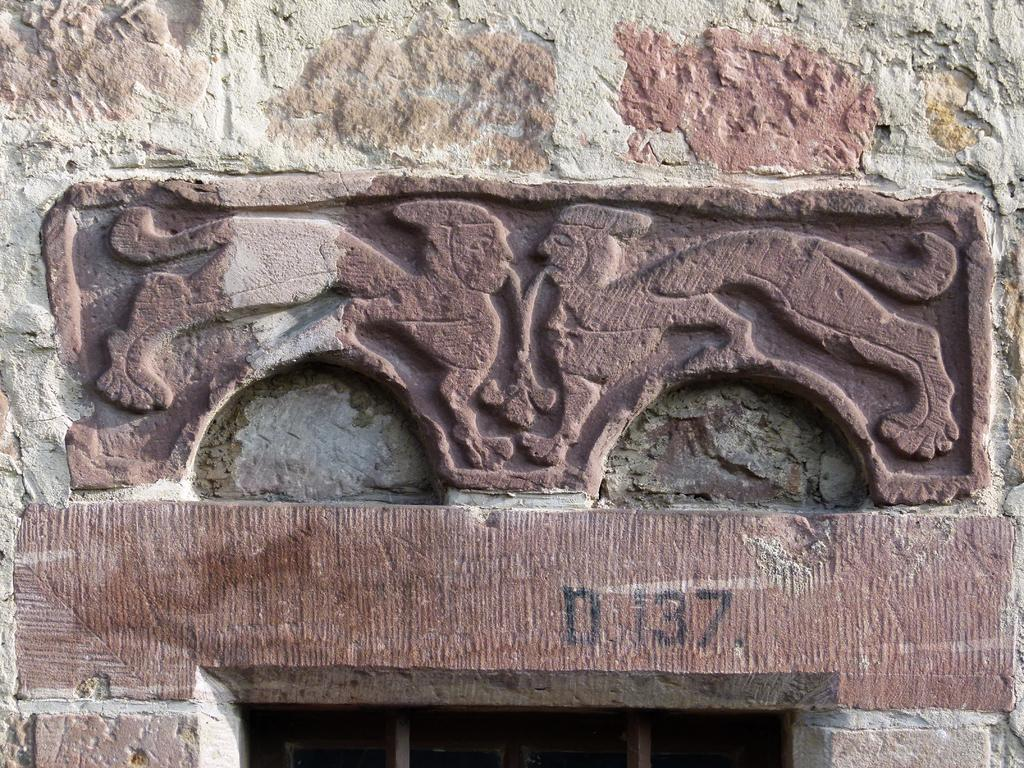What is depicted on the wall in the image? There is a sculpture on the wall in the image. What else can be seen near the sculpture? There is text below the sculpture in the image. What type of lumber is floating in the river in the image? There is no river or lumber present in the image; it only features a sculpture on the wall with text below it. 